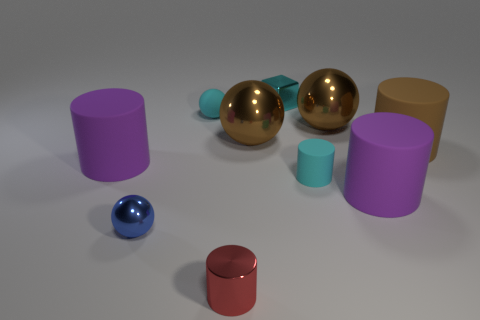Subtract 1 spheres. How many spheres are left? 3 Subtract all cyan cylinders. How many cylinders are left? 4 Subtract all brown cylinders. How many cylinders are left? 4 Subtract all green spheres. Subtract all green cylinders. How many spheres are left? 4 Subtract all spheres. How many objects are left? 6 Add 5 tiny cyan metal things. How many tiny cyan metal things exist? 6 Subtract 1 cyan spheres. How many objects are left? 9 Subtract all brown balls. Subtract all metal balls. How many objects are left? 5 Add 5 cyan matte cylinders. How many cyan matte cylinders are left? 6 